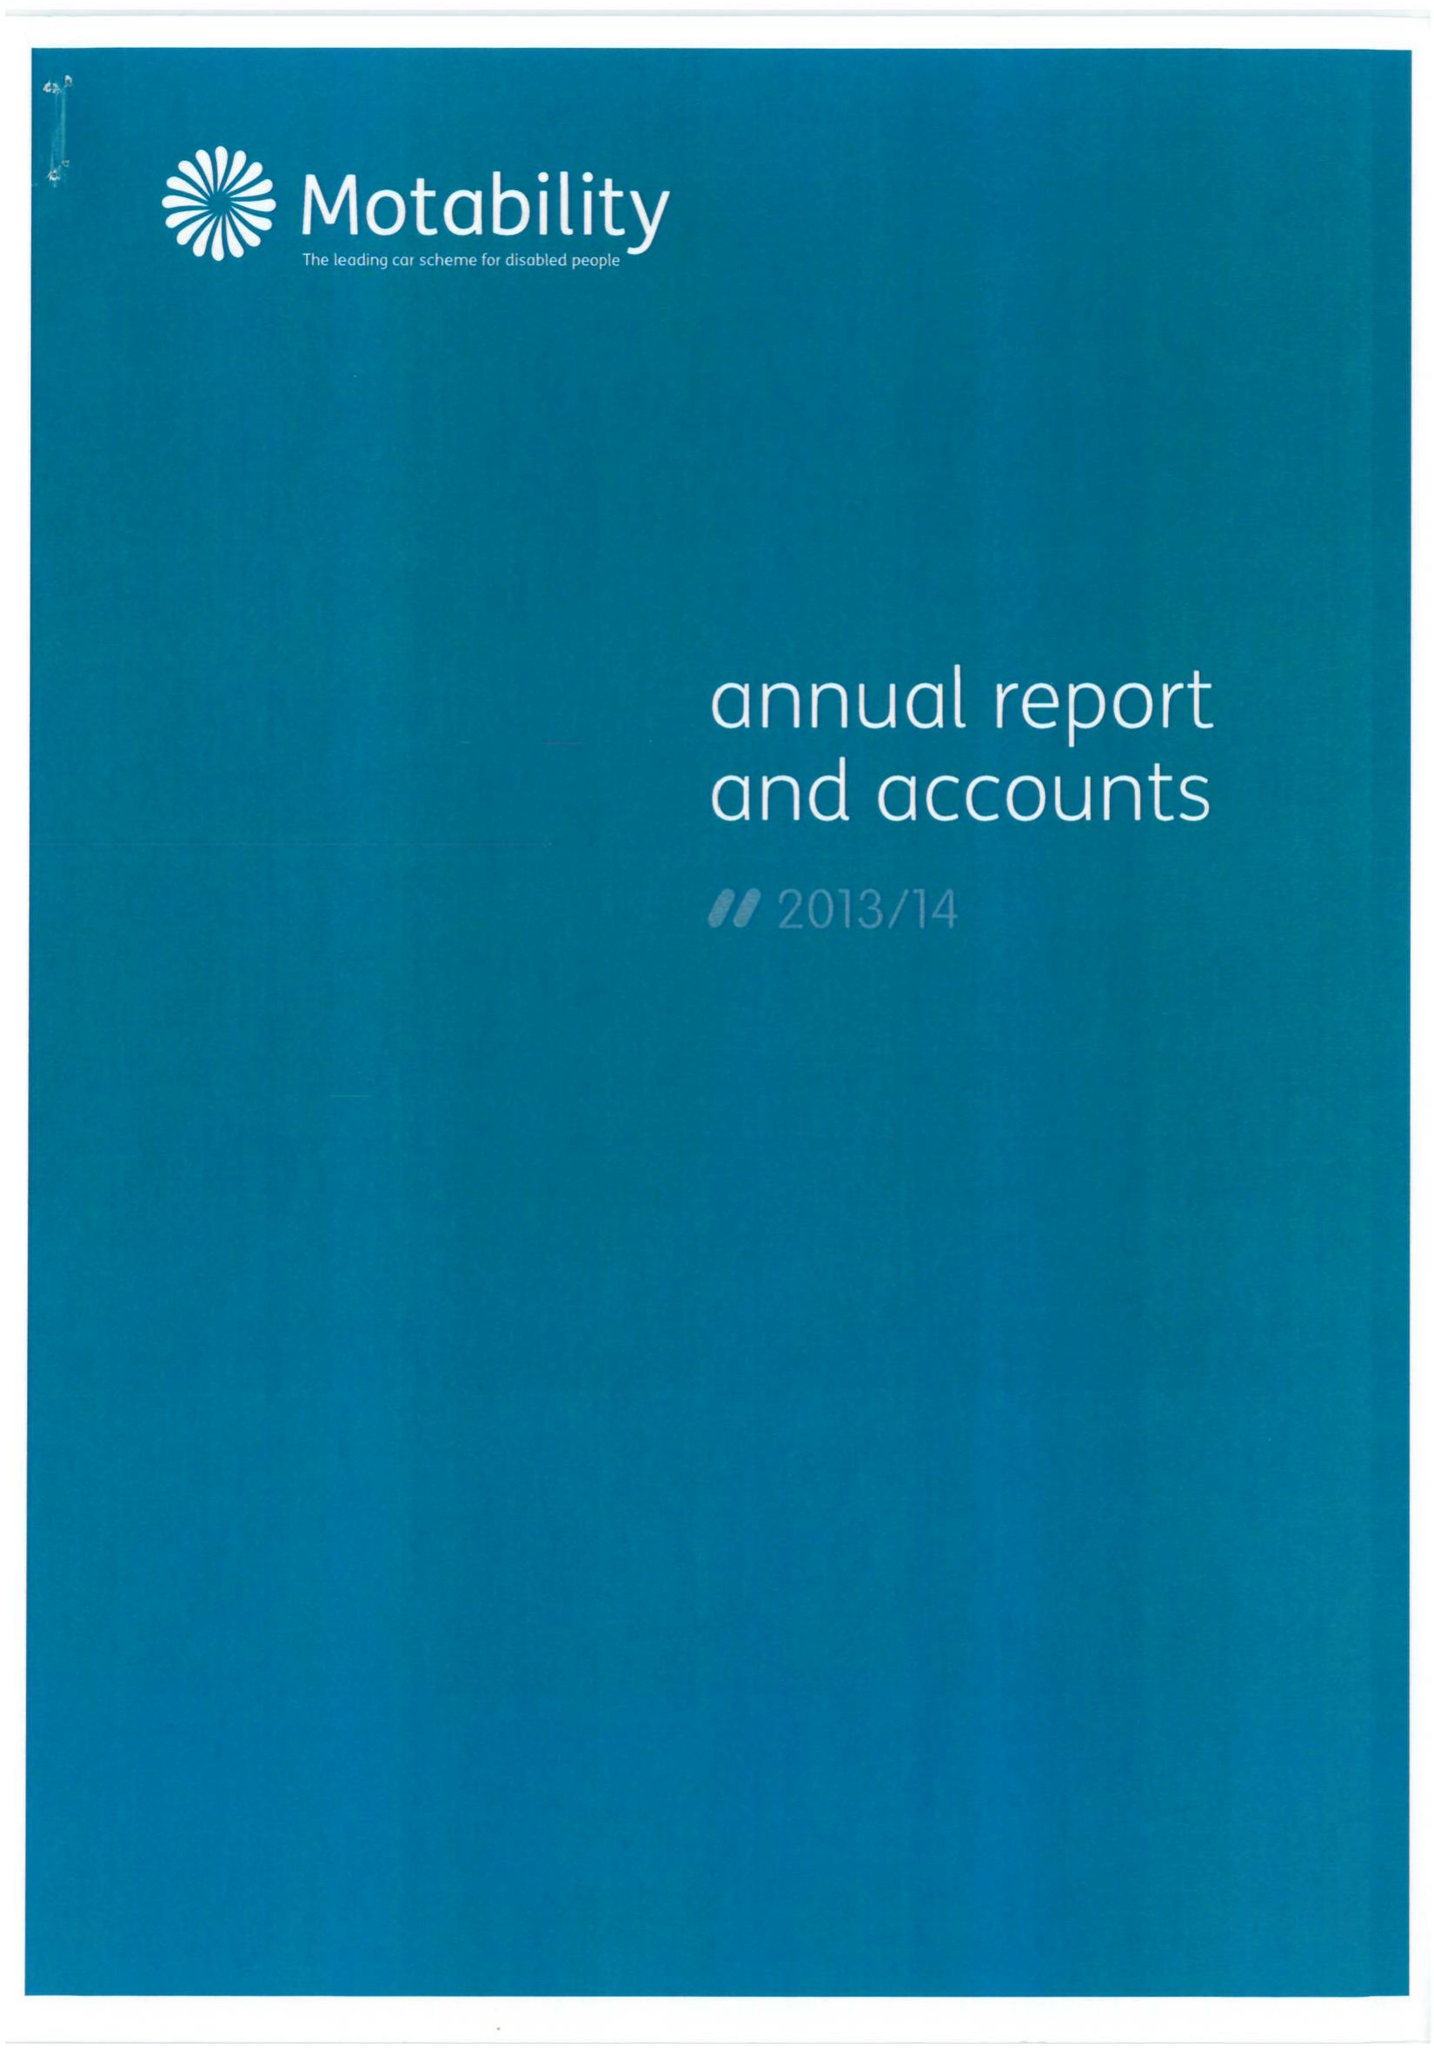What is the value for the address__post_town?
Answer the question using a single word or phrase. HARLOW 